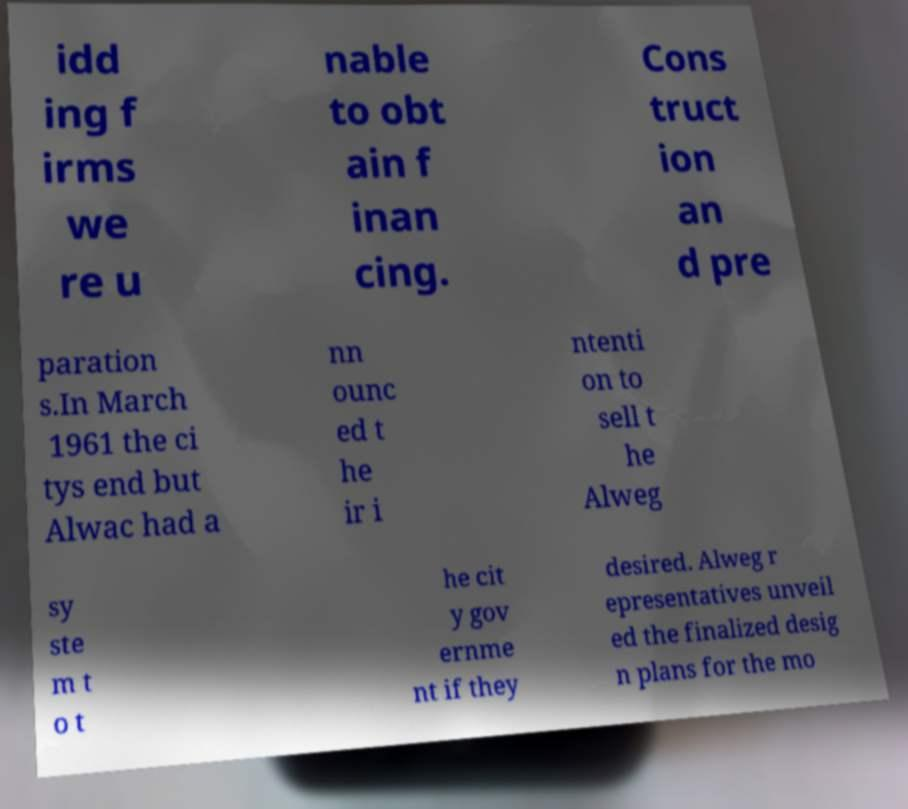For documentation purposes, I need the text within this image transcribed. Could you provide that? idd ing f irms we re u nable to obt ain f inan cing. Cons truct ion an d pre paration s.In March 1961 the ci tys end but Alwac had a nn ounc ed t he ir i ntenti on to sell t he Alweg sy ste m t o t he cit y gov ernme nt if they desired. Alweg r epresentatives unveil ed the finalized desig n plans for the mo 